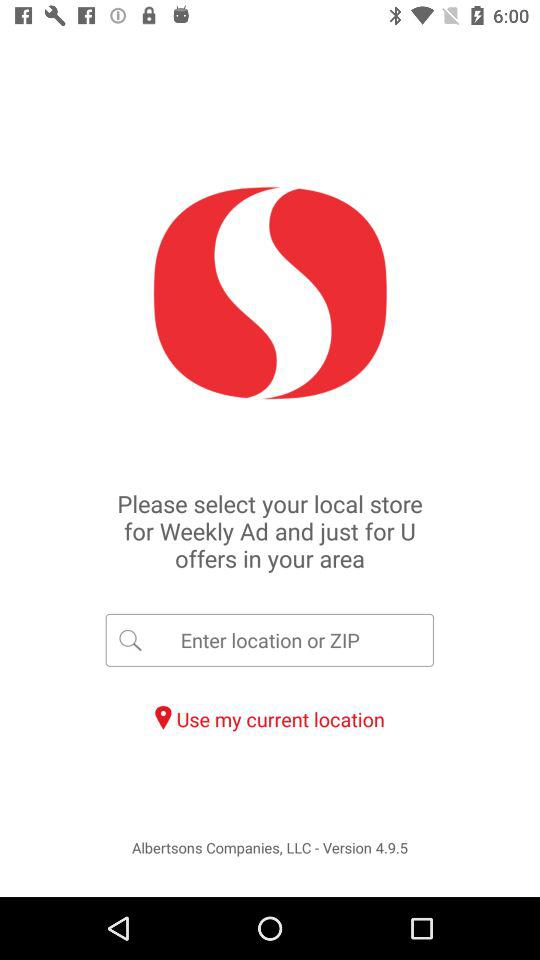Which options are given for entering the location?
When the provided information is insufficient, respond with <no answer>. <no answer> 